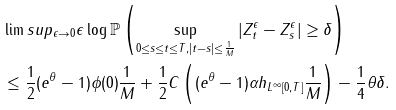Convert formula to latex. <formula><loc_0><loc_0><loc_500><loc_500>& \lim s u p _ { \epsilon \rightarrow 0 } \epsilon \log \mathbb { P } \left ( \sup _ { 0 \leq s \leq t \leq T , | t - s | \leq \frac { 1 } { M } } | Z _ { t } ^ { \epsilon } - Z _ { s } ^ { \epsilon } | \geq \delta \right ) \\ & \leq \frac { 1 } { 2 } ( e ^ { \theta } - 1 ) \phi ( 0 ) \frac { 1 } { M } + \frac { 1 } { 2 } C \left ( ( e ^ { \theta } - 1 ) \alpha \| h \| _ { L ^ { \infty } [ 0 , T ] } \frac { 1 } { M } \right ) - \frac { 1 } { 4 } \theta \delta .</formula> 